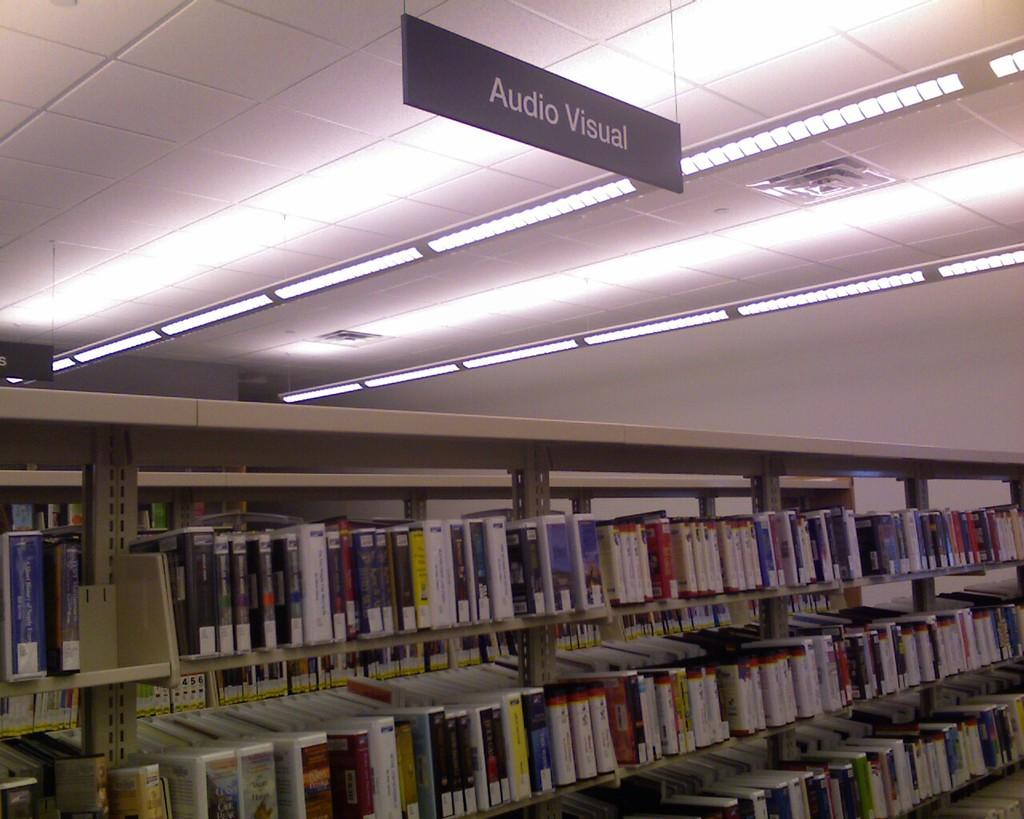What type of furniture is present in the image? There are cupboards in the image. What can be seen on top of the cupboards? There are many books on the cupboards. What is the source of light in the image? There are lights on the ceiling. What is hanging from the ceiling? There is a board hanged on the ceiling. Can you tell me how many grapes are on the board hanging from the ceiling? There are no grapes present on the board hanging from the ceiling in the image. What type of alarm is attached to the cupboards? There is no alarm attached to the cupboards in the image. 